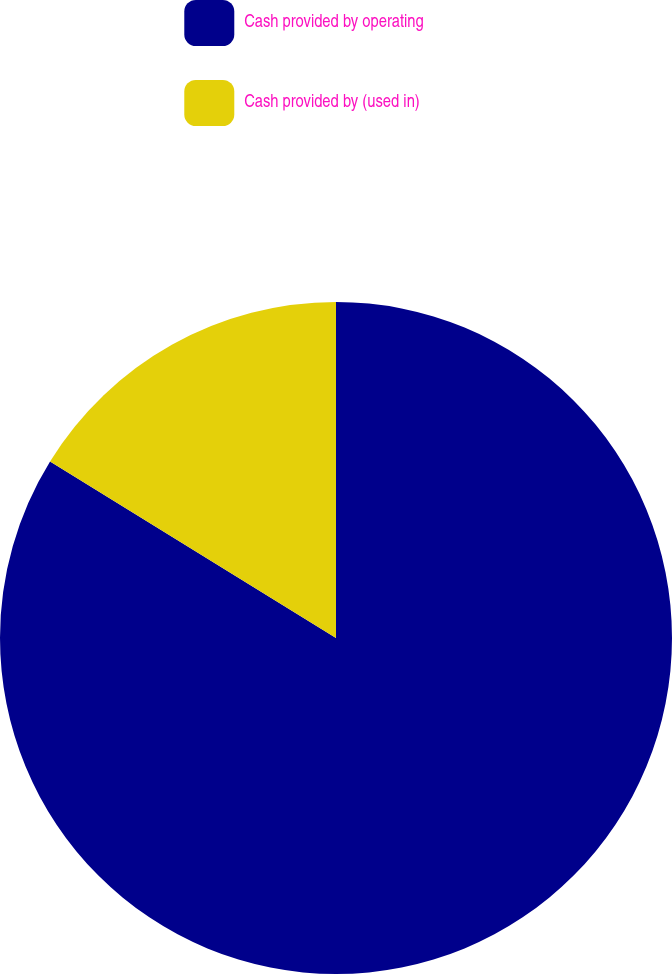Convert chart. <chart><loc_0><loc_0><loc_500><loc_500><pie_chart><fcel>Cash provided by operating<fcel>Cash provided by (used in)<nl><fcel>83.8%<fcel>16.2%<nl></chart> 